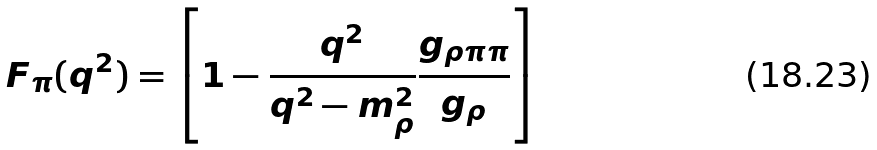Convert formula to latex. <formula><loc_0><loc_0><loc_500><loc_500>F _ { \pi } ( q ^ { 2 } ) = \left [ 1 - \frac { q ^ { 2 } } { q ^ { 2 } - m ^ { 2 } _ { \rho } } \frac { g _ { \rho \pi \pi } } { g _ { \rho } } \right ]</formula> 